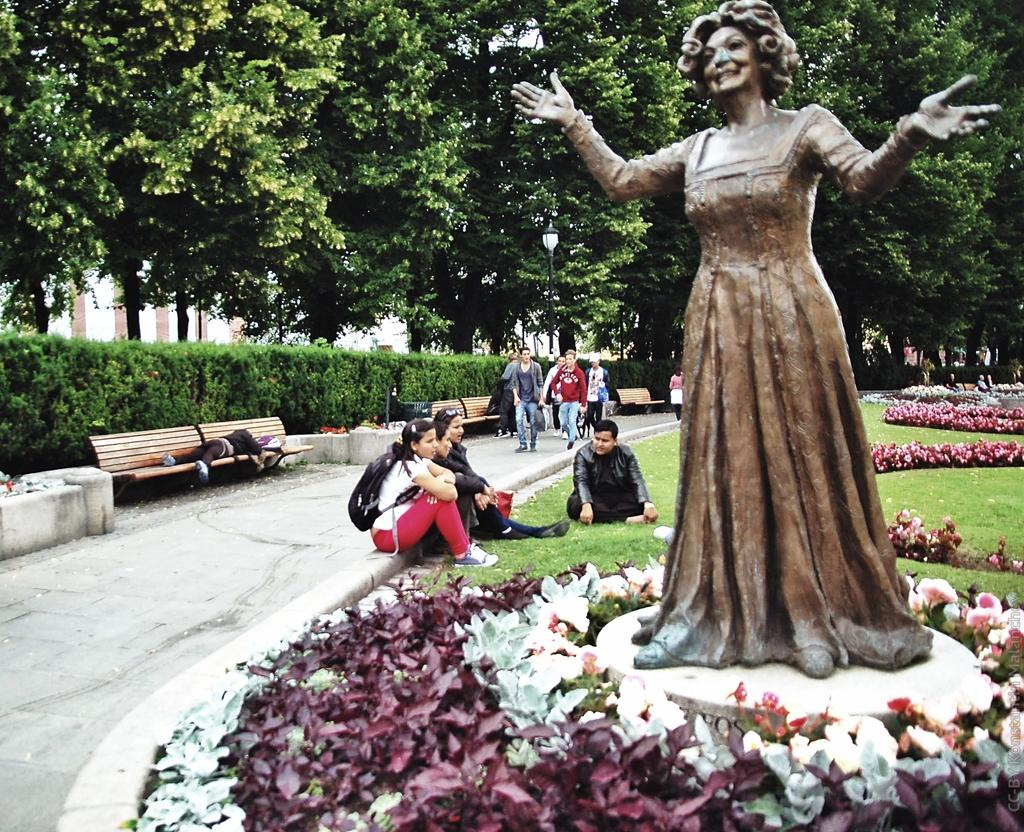What is the main subject in the image? There is a lady statue in the image. What is happening in the background of the image? There are people sitting and walking in the background of the image. What type of natural environment is visible in the image? There are many trees in the background of the image. What type of degree does the lady statue have in the image? The lady statue is not a real person and therefore does not have a degree. 